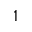<formula> <loc_0><loc_0><loc_500><loc_500>^ { 1 }</formula> 